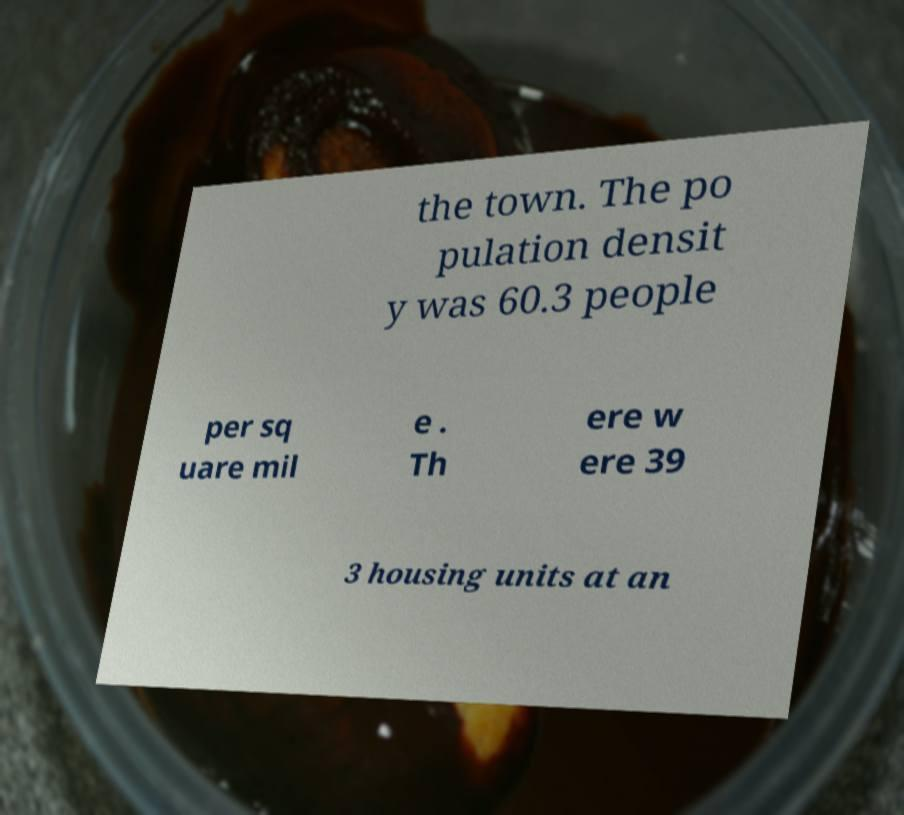Could you assist in decoding the text presented in this image and type it out clearly? the town. The po pulation densit y was 60.3 people per sq uare mil e . Th ere w ere 39 3 housing units at an 